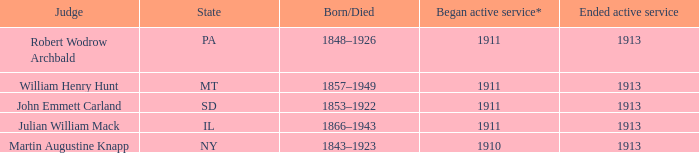Who was the judge for the state SD? John Emmett Carland. 